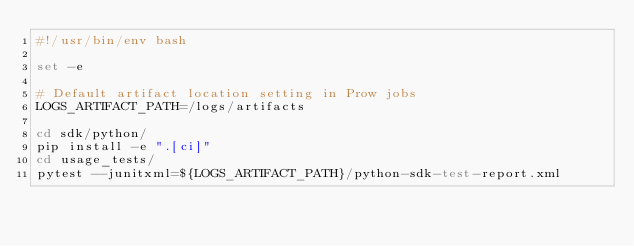<code> <loc_0><loc_0><loc_500><loc_500><_Bash_>#!/usr/bin/env bash

set -e

# Default artifact location setting in Prow jobs
LOGS_ARTIFACT_PATH=/logs/artifacts

cd sdk/python/
pip install -e ".[ci]"
cd usage_tests/
pytest --junitxml=${LOGS_ARTIFACT_PATH}/python-sdk-test-report.xml
</code> 